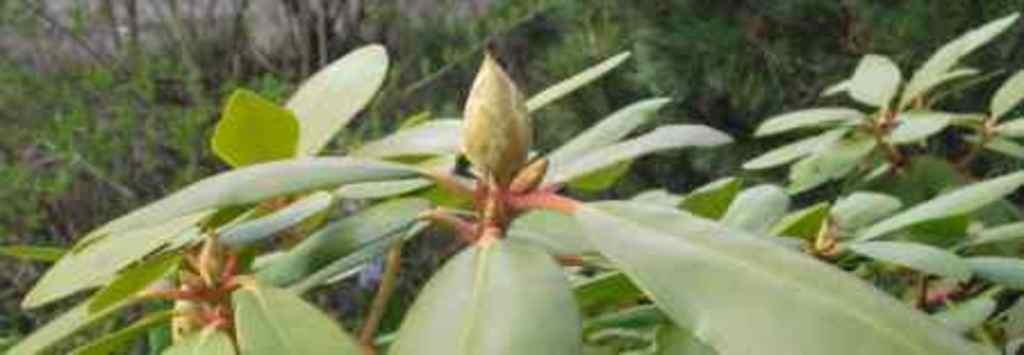What is visible in the foreground of the image? There are leaves in the foreground of the image. What can be seen in the background of the image? There are trees in the background of the image. How many brothers are playing the rhythm on the leaves in the image? There are no brothers or any indication of rhythm in the image; it features leaves in the foreground and trees in the background. What type of mitten can be seen on the tree in the image? There is no mitten present on the tree or anywhere else in the image. 